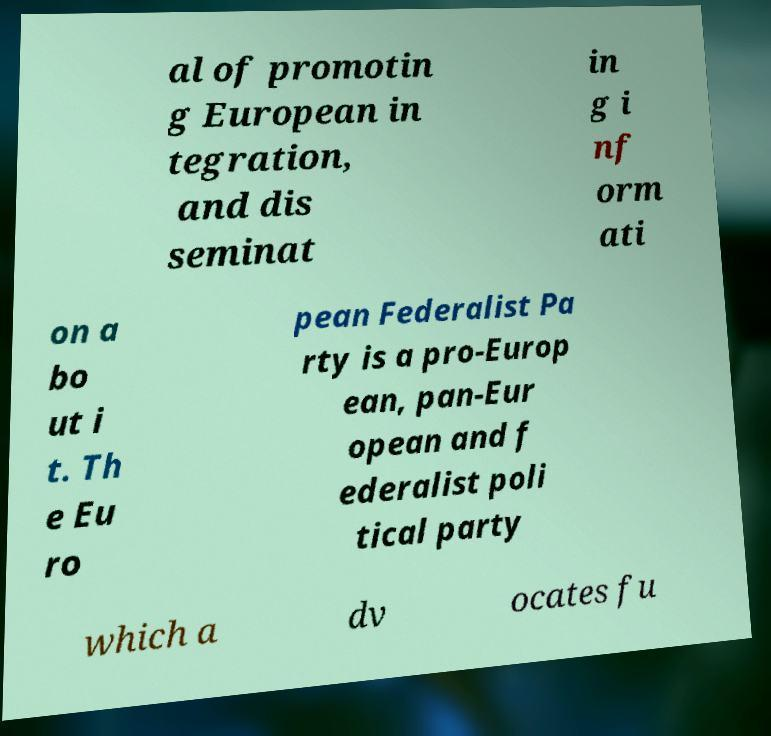Please identify and transcribe the text found in this image. al of promotin g European in tegration, and dis seminat in g i nf orm ati on a bo ut i t. Th e Eu ro pean Federalist Pa rty is a pro-Europ ean, pan-Eur opean and f ederalist poli tical party which a dv ocates fu 